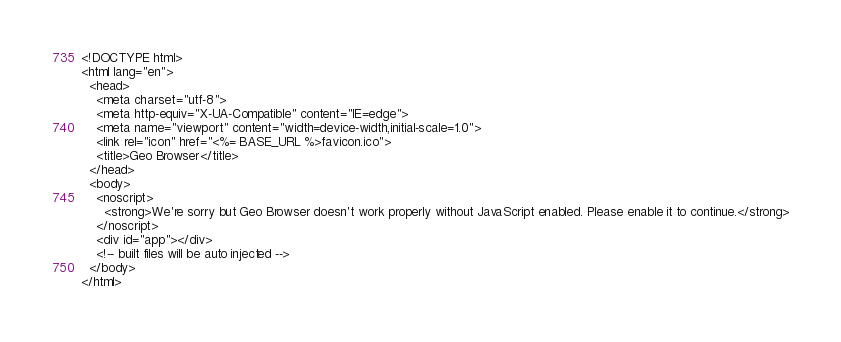Convert code to text. <code><loc_0><loc_0><loc_500><loc_500><_HTML_><!DOCTYPE html>
<html lang="en">
  <head>
    <meta charset="utf-8">
    <meta http-equiv="X-UA-Compatible" content="IE=edge">
    <meta name="viewport" content="width=device-width,initial-scale=1.0">
    <link rel="icon" href="<%= BASE_URL %>favicon.ico">
    <title>Geo Browser</title>
  </head>
  <body>
    <noscript>
      <strong>We're sorry but Geo Browser doesn't work properly without JavaScript enabled. Please enable it to continue.</strong>
    </noscript>
    <div id="app"></div>
    <!-- built files will be auto injected -->
  </body>
</html>
</code> 